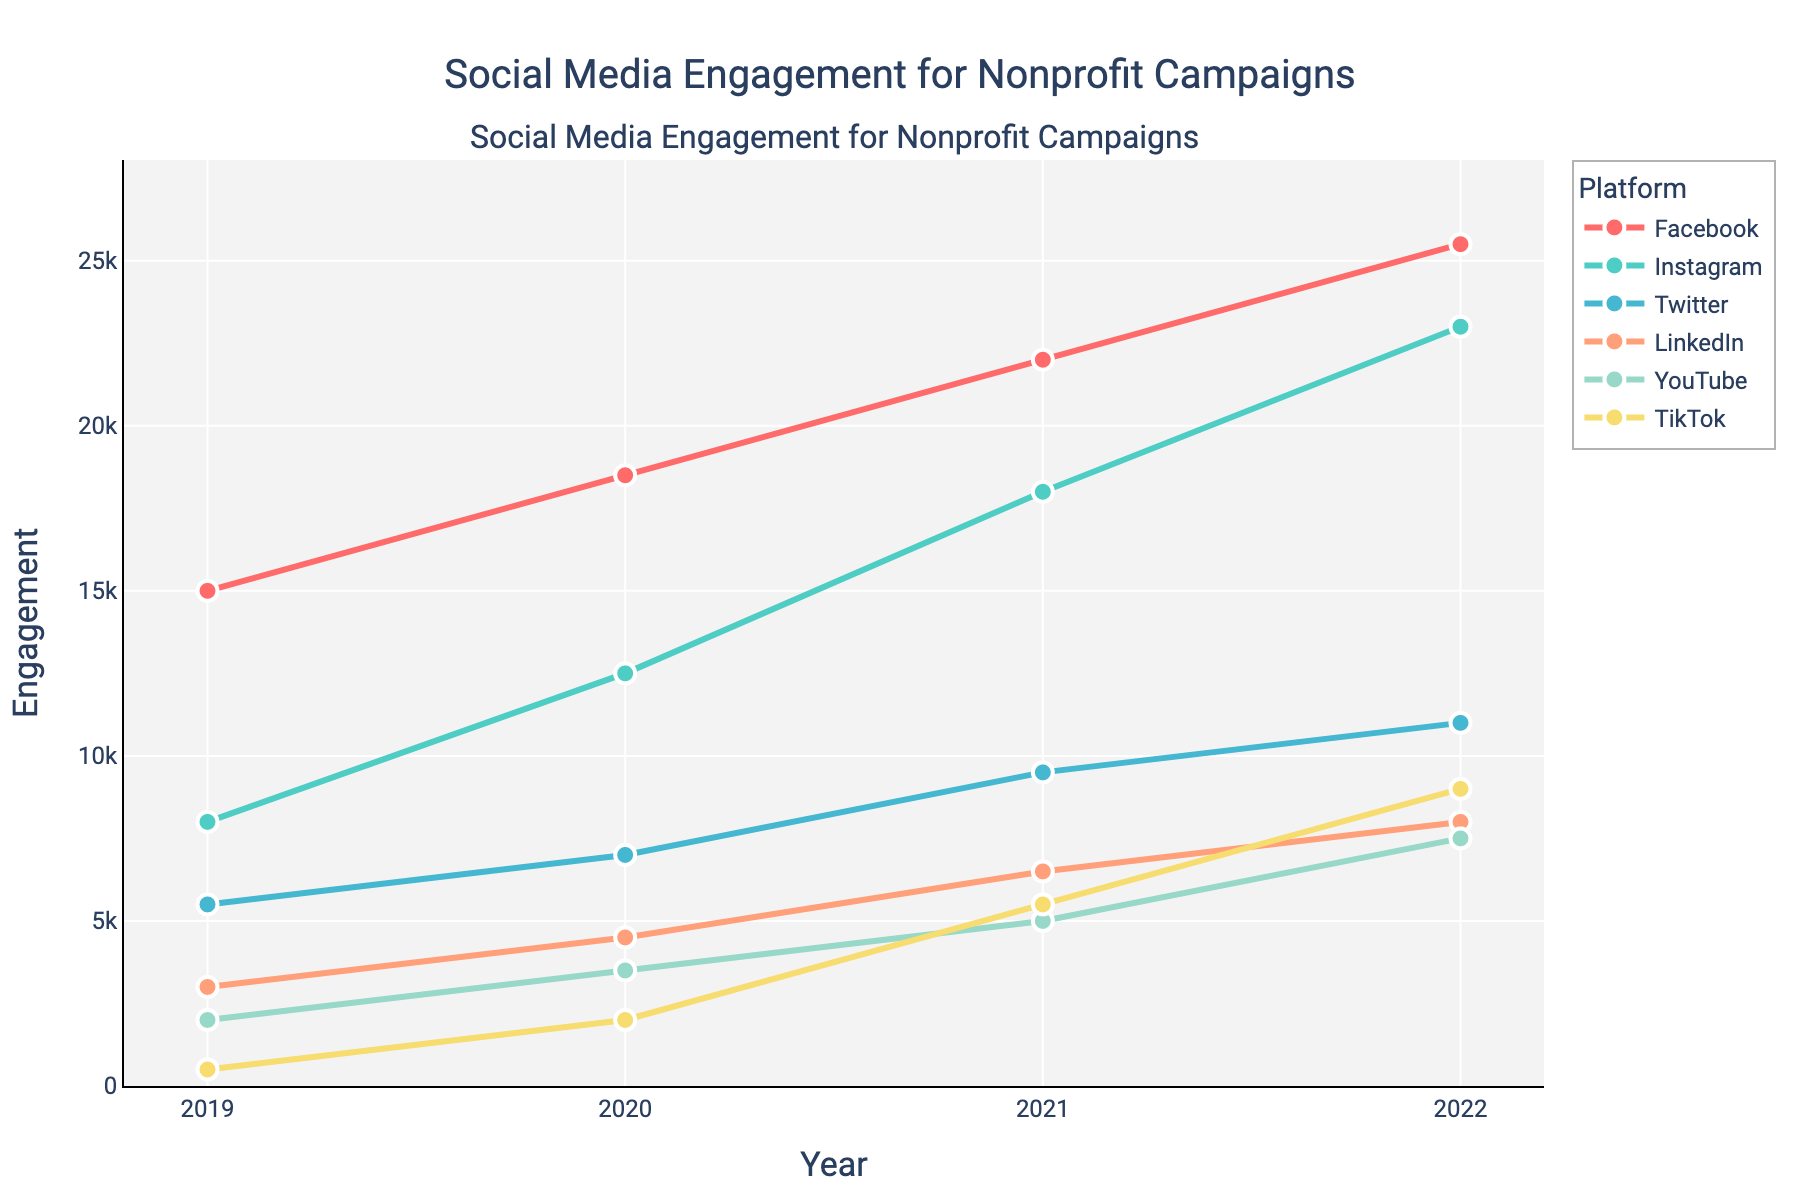What's the overall trend in social media engagement across all platforms from 2019 to 2022? By observing the line chart, all platforms show an increasing trend in engagement over the years from 2019 to 2022. Facebook, Instagram, Twitter, LinkedIn, YouTube, and TikTok all demonstrate a consistent rise.
Answer: Increasing Which platform had the highest engagement in 2022? By comparing the heights of the lines for each platform in the year 2022, Facebook had the highest engagement in 2022, reaching approximately 25,500 engagements.
Answer: Facebook How did TikTok's engagement change from 2019 to 2022? TikTok had the lowest engagement in 2019 with only 500 engagements. By 2022, this number grew to 9,000 engagements, indicating a significant increase.
Answer: Increased significantly Which two platforms had the smallest increase in engagement from 2019 to 2022? By calculating the increase in engagement for each platform: Facebook (10,500), Instagram (15,000), Twitter (5,500), LinkedIn (5,000), YouTube (5,500), TikTok (8,500), it is apparent Twitter and LinkedIn had the smallest increases.
Answer: Twitter and LinkedIn What is the average engagement across all platforms for the year 2021? To find the average for 2021, sum the engagements for all platforms in that year and divide by the number of platforms. So, (22000 + 18000 + 9500 + 6500 + 5000 + 5500) / 6 = 67500 / 6 = 11250.
Answer: 11250 How does Instagram's engagement in 2020 compare to YouTube's engagement in 2021? Instagram's engagement in 2020 was 12,500 while YouTube's engagement in 2021 was 5,000. Thus, Instagram's engagement was higher in 2020 compared to YouTube's in 2021.
Answer: Higher Between Instagram and Twitter, which platform had a greater relative increase in engagement from 2019 to 2022? Instagram's engagement increased from 8,000 to 23,000, an increase of 15,000 which is almost 1.875 times its 2019 engagement. Twitter's increased from 5,500 to 11,000, an increase of 5,500 which is exactly 1 time its 2019 engagement. Therefore, Instagram had a greater relative increase.
Answer: Instagram What is the total engagement across all platforms in 2022? Adding up the engagement values for all platforms in 2022 results in 25,500 (Facebook) + 23,000 (Instagram) + 11,000 (Twitter) + 8,000 (LinkedIn) + 7,500 (YouTube) + 9,000 (TikTok) = 84,000.
Answer: 84,000 Which platform's engagement grew more steadily over the years, TikTok or LinkedIn? By observing the slope of the lines for TikTok and LinkedIn, LinkedIn shows a steadier and more linear increase, while TikTok’s engagements show a sharp non-linear increase.
Answer: LinkedIn 